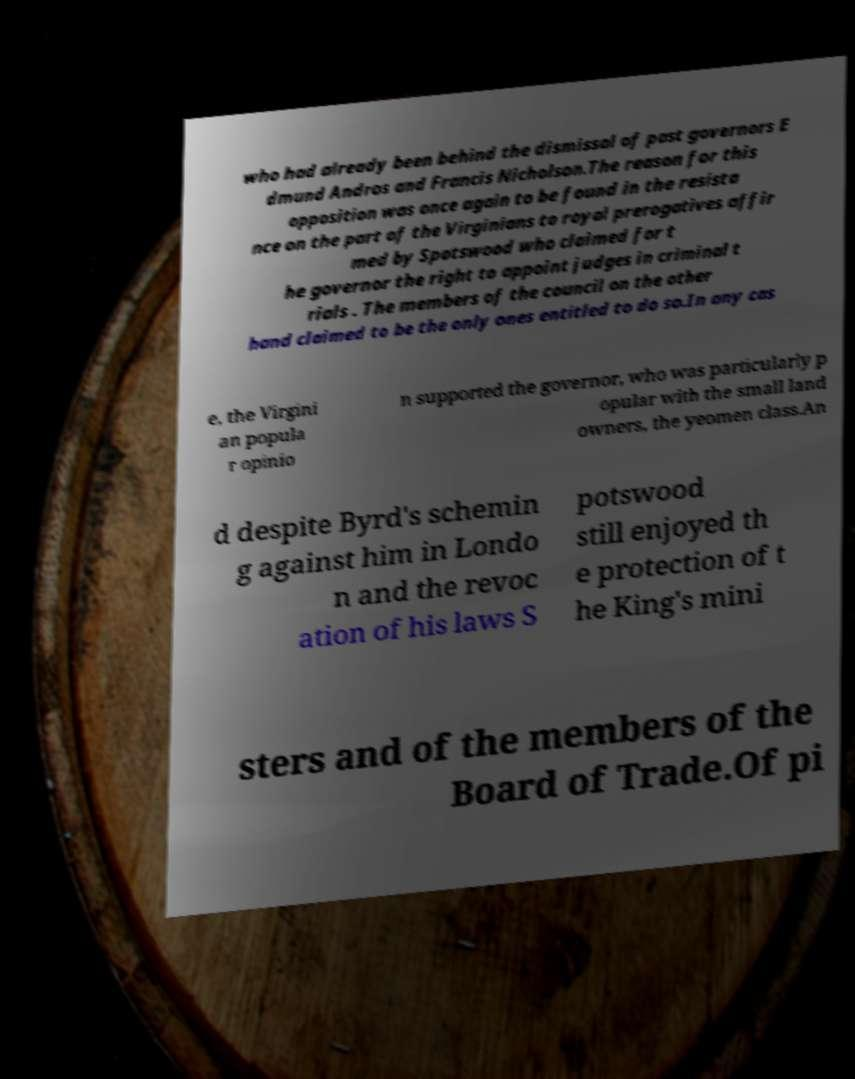Can you accurately transcribe the text from the provided image for me? who had already been behind the dismissal of past governors E dmund Andros and Francis Nicholson.The reason for this opposition was once again to be found in the resista nce on the part of the Virginians to royal prerogatives affir med by Spotswood who claimed for t he governor the right to appoint judges in criminal t rials . The members of the council on the other hand claimed to be the only ones entitled to do so.In any cas e, the Virgini an popula r opinio n supported the governor, who was particularly p opular with the small land owners, the yeomen class.An d despite Byrd's schemin g against him in Londo n and the revoc ation of his laws S potswood still enjoyed th e protection of t he King's mini sters and of the members of the Board of Trade.Of pi 